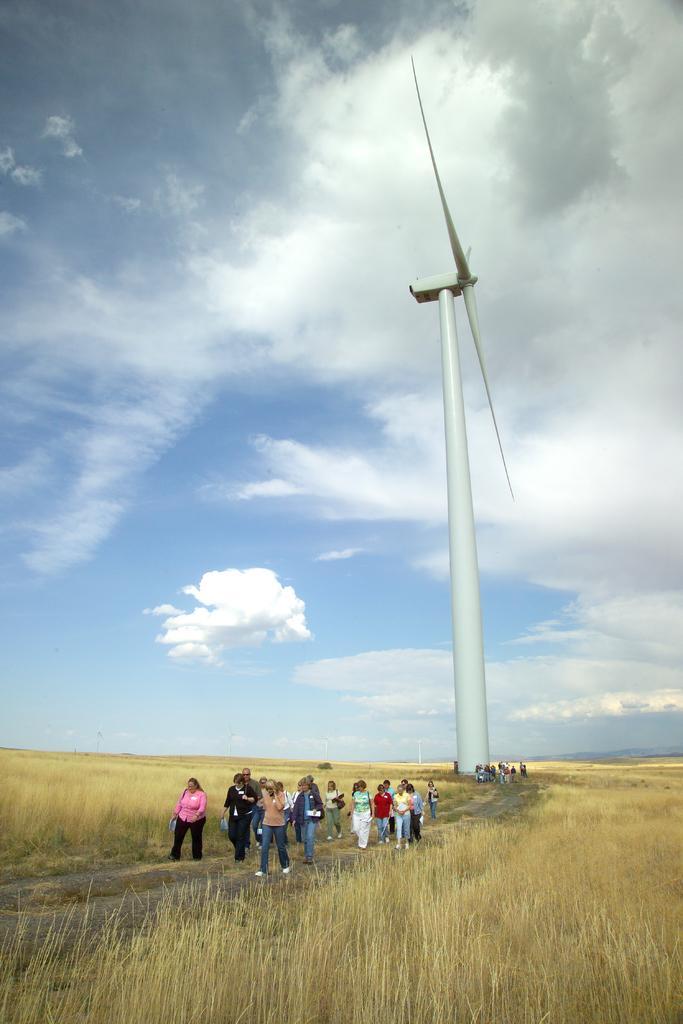Describe this image in one or two sentences. In this image, we can see a white windmill. Here we can see a group of people and plants. Background there is a cloudy sky. 